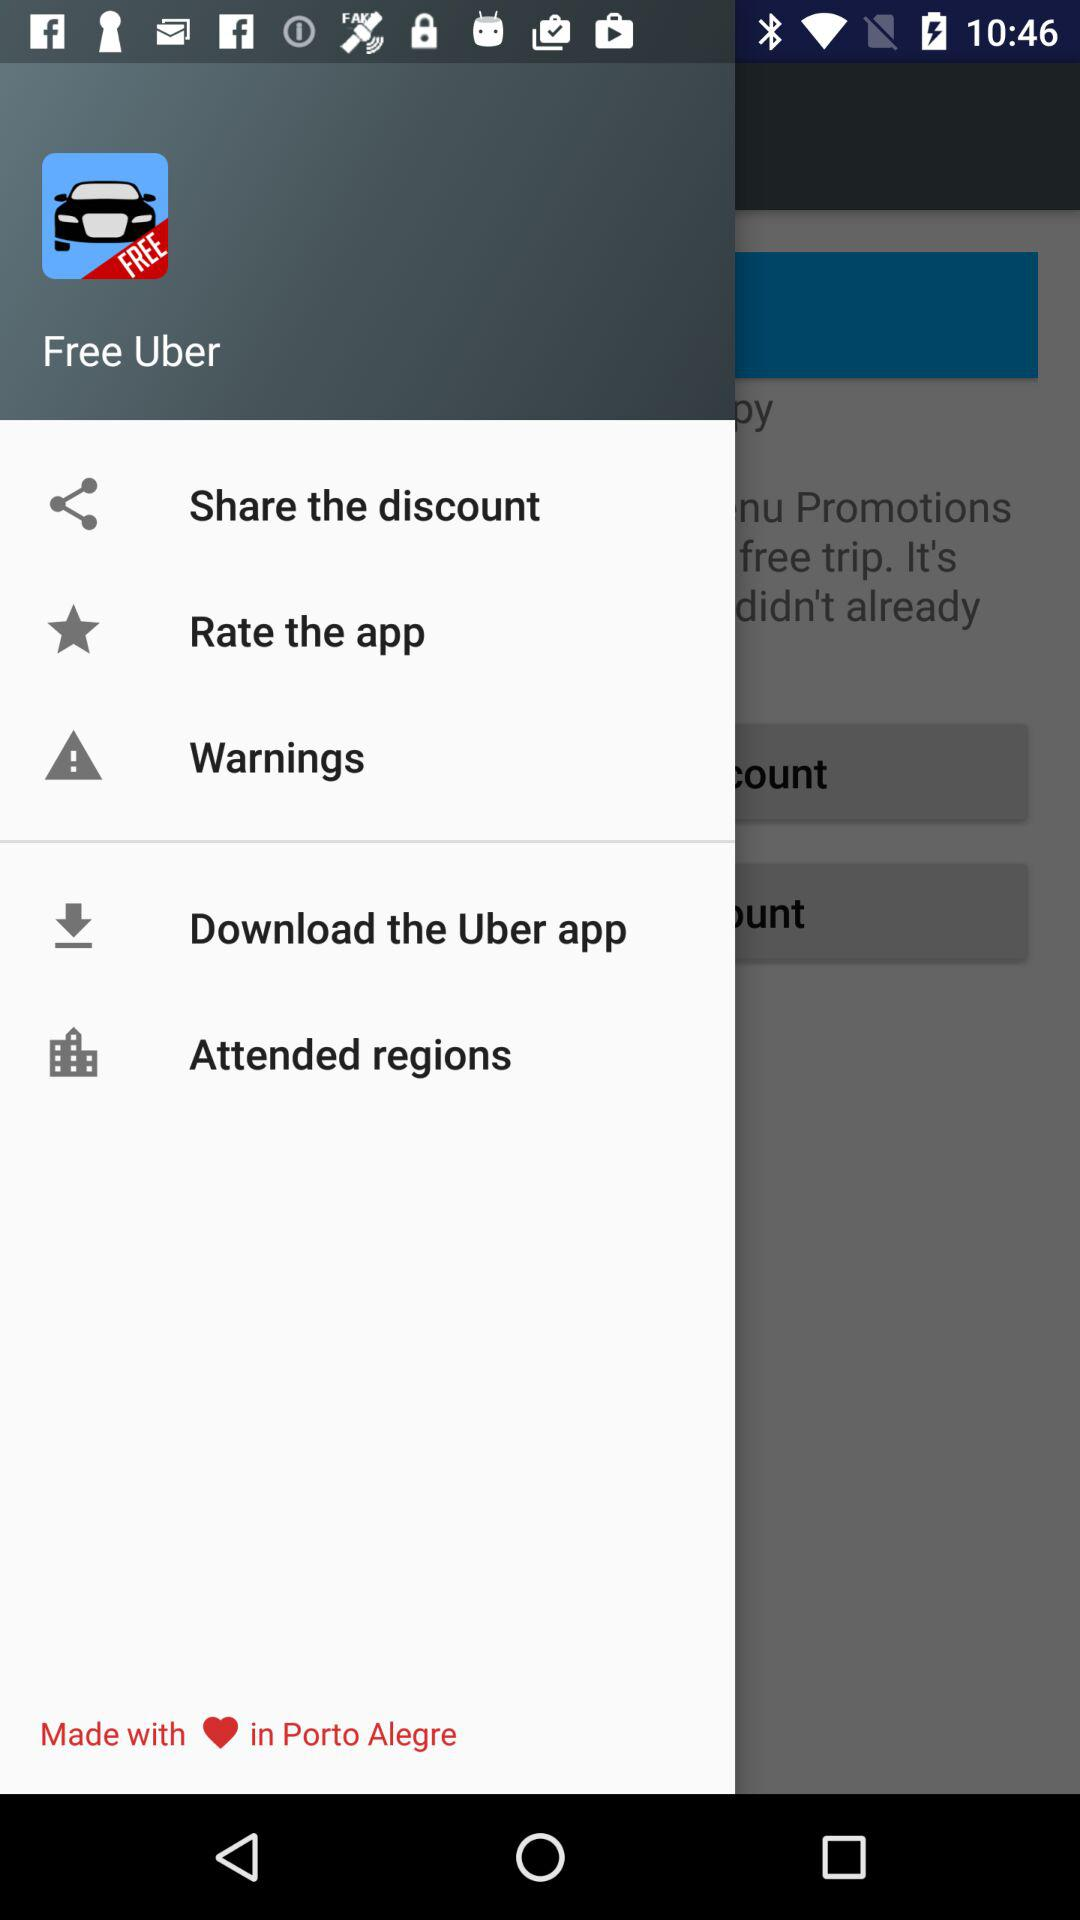Where did this application come from? This application comes from Porto Alegre. 